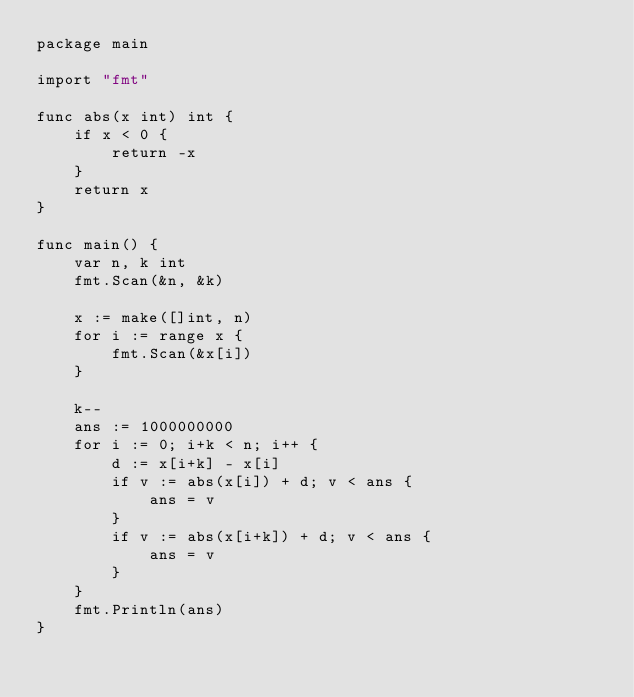<code> <loc_0><loc_0><loc_500><loc_500><_Go_>package main

import "fmt"

func abs(x int) int {
	if x < 0 {
		return -x
	}
	return x
}

func main() {
	var n, k int
	fmt.Scan(&n, &k)

	x := make([]int, n)
	for i := range x {
		fmt.Scan(&x[i])
	}

	k--
	ans := 1000000000
	for i := 0; i+k < n; i++ {
		d := x[i+k] - x[i]
		if v := abs(x[i]) + d; v < ans {
			ans = v
		}
		if v := abs(x[i+k]) + d; v < ans {
			ans = v
		}
	}
	fmt.Println(ans)
}
</code> 